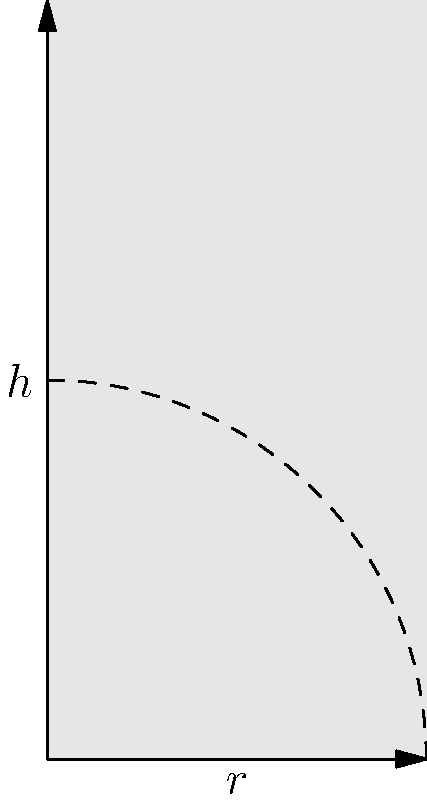A cylindrical water tank at a military base needs to be filled precisely for an upcoming drill. The tank has a radius of 2 meters and a height of 4 meters. As the commanding officer, you need to calculate the exact volume of water needed to fill the tank. Using the method of integration, determine the volume of the cylindrical tank in cubic meters. Round your answer to two decimal places. To find the volume of a cylindrical tank using integration, we follow these steps:

1) The volume of a cylinder can be calculated by integrating the area of circular cross-sections along the height of the cylinder.

2) The formula for the area of a circle is $A = \pi r^2$, where $r$ is the radius.

3) We set up the integral:
   $$V = \int_0^h \pi r^2 dh$$
   where $h$ is the height of the cylinder.

4) In this case, $r = 2$ meters and $h = 4$ meters.

5) Substituting these values:
   $$V = \int_0^4 \pi (2)^2 dh$$

6) Simplify:
   $$V = \int_0^4 4\pi dh$$

7) Integrate:
   $$V = 4\pi h \bigg|_0^4$$

8) Evaluate the integral:
   $$V = 4\pi(4) - 4\pi(0) = 16\pi$$

9) Calculate the final value:
   $$V = 16\pi \approx 50.27 \text{ cubic meters}$$

10) Rounding to two decimal places: 50.27 cubic meters.
Answer: 50.27 cubic meters 